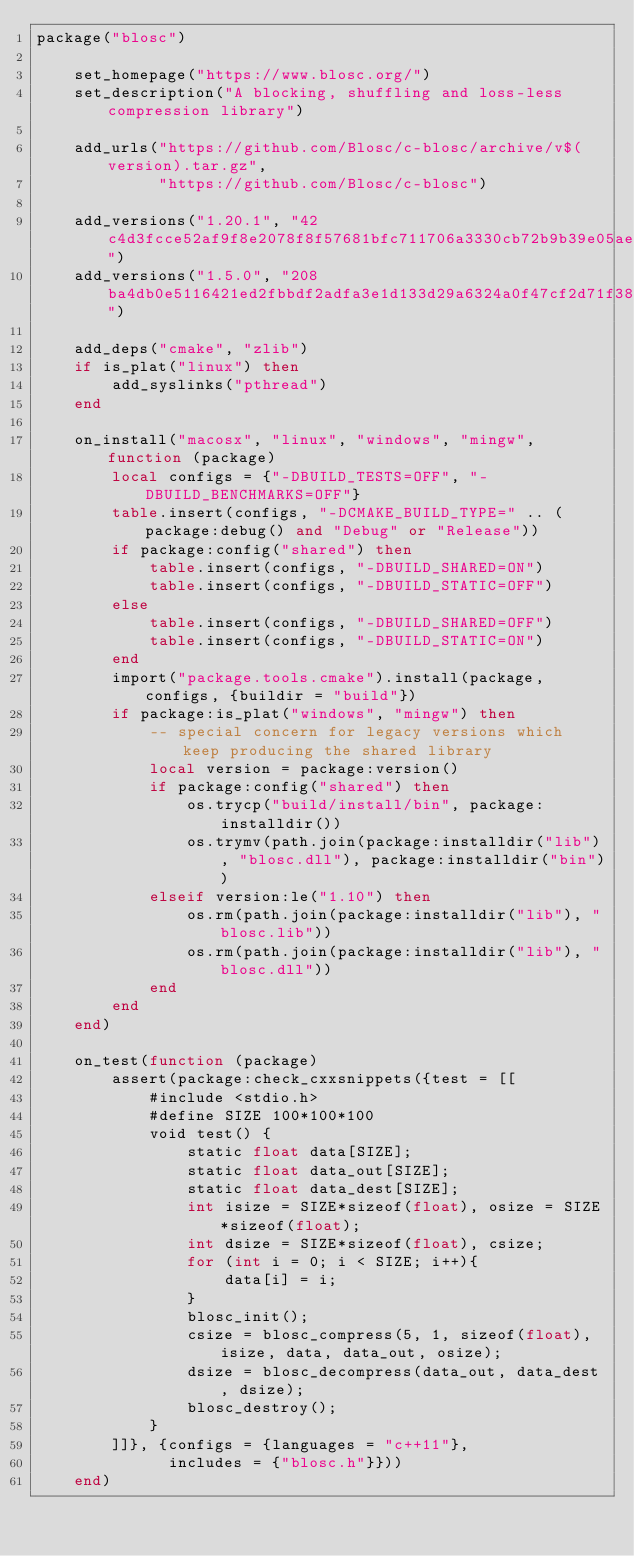Convert code to text. <code><loc_0><loc_0><loc_500><loc_500><_Lua_>package("blosc")

    set_homepage("https://www.blosc.org/")
    set_description("A blocking, shuffling and loss-less compression library")

    add_urls("https://github.com/Blosc/c-blosc/archive/v$(version).tar.gz",
             "https://github.com/Blosc/c-blosc")

    add_versions("1.20.1", "42c4d3fcce52af9f8e2078f8f57681bfc711706a3330cb72b9b39e05ae18a413")
    add_versions("1.5.0", "208ba4db0e5116421ed2fbbdf2adfa3e1d133d29a6324a0f47cf2d71f3810c92")

    add_deps("cmake", "zlib")
    if is_plat("linux") then
        add_syslinks("pthread")
    end

    on_install("macosx", "linux", "windows", "mingw", function (package)
        local configs = {"-DBUILD_TESTS=OFF", "-DBUILD_BENCHMARKS=OFF"}
        table.insert(configs, "-DCMAKE_BUILD_TYPE=" .. (package:debug() and "Debug" or "Release"))
        if package:config("shared") then
            table.insert(configs, "-DBUILD_SHARED=ON")
            table.insert(configs, "-DBUILD_STATIC=OFF")
        else
            table.insert(configs, "-DBUILD_SHARED=OFF")
            table.insert(configs, "-DBUILD_STATIC=ON")
        end
        import("package.tools.cmake").install(package, configs, {buildir = "build"})
        if package:is_plat("windows", "mingw") then
            -- special concern for legacy versions which keep producing the shared library
            local version = package:version()
            if package:config("shared") then
                os.trycp("build/install/bin", package:installdir())
                os.trymv(path.join(package:installdir("lib"), "blosc.dll"), package:installdir("bin"))
            elseif version:le("1.10") then
                os.rm(path.join(package:installdir("lib"), "blosc.lib"))
                os.rm(path.join(package:installdir("lib"), "blosc.dll"))
            end
        end
    end)

    on_test(function (package)
        assert(package:check_cxxsnippets({test = [[
            #include <stdio.h>
            #define SIZE 100*100*100
            void test() {
                static float data[SIZE];
                static float data_out[SIZE];
                static float data_dest[SIZE];
                int isize = SIZE*sizeof(float), osize = SIZE*sizeof(float);
                int dsize = SIZE*sizeof(float), csize;
                for (int i = 0; i < SIZE; i++){
                    data[i] = i;
                }
                blosc_init();
                csize = blosc_compress(5, 1, sizeof(float), isize, data, data_out, osize);
                dsize = blosc_decompress(data_out, data_dest, dsize);
                blosc_destroy();
            }
        ]]}, {configs = {languages = "c++11"},
              includes = {"blosc.h"}}))
    end)
</code> 